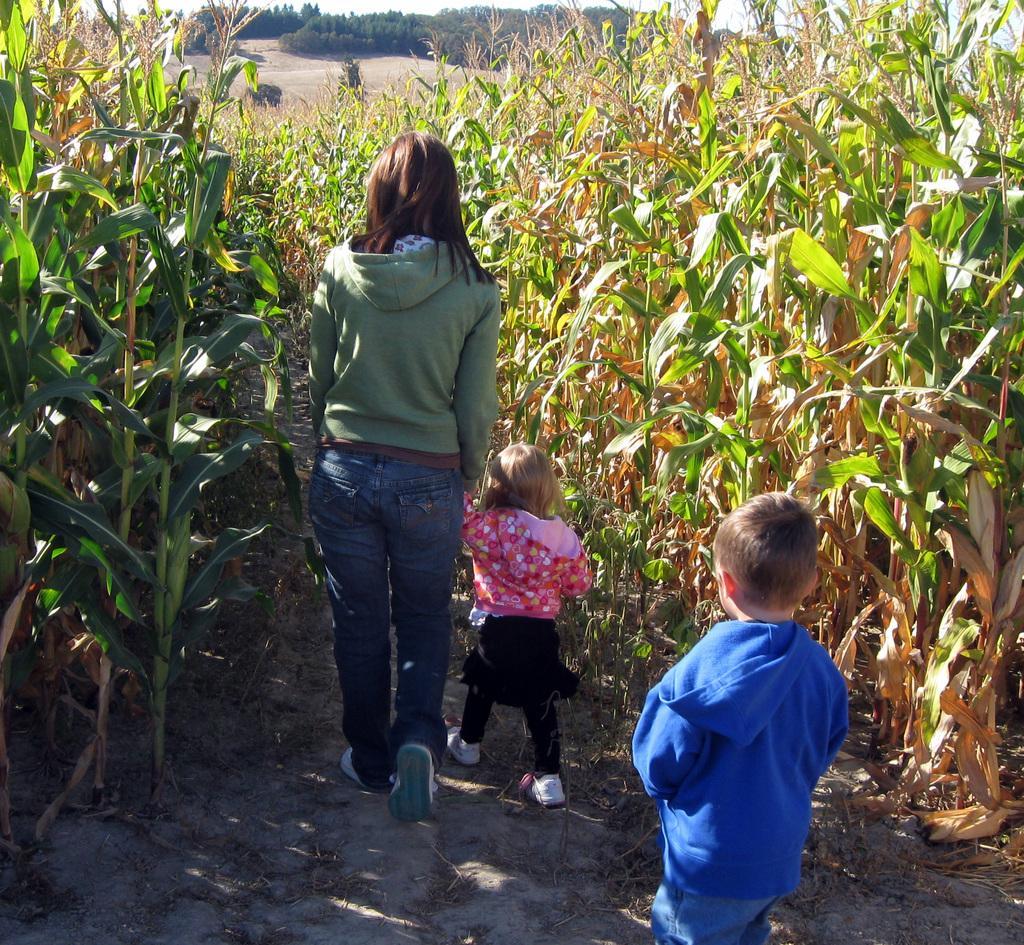Could you give a brief overview of what you see in this image? In this image I can see three people walking and wearing different color dresses. On both sides I can see few plants in green and brown color. Back I can see few trees. 